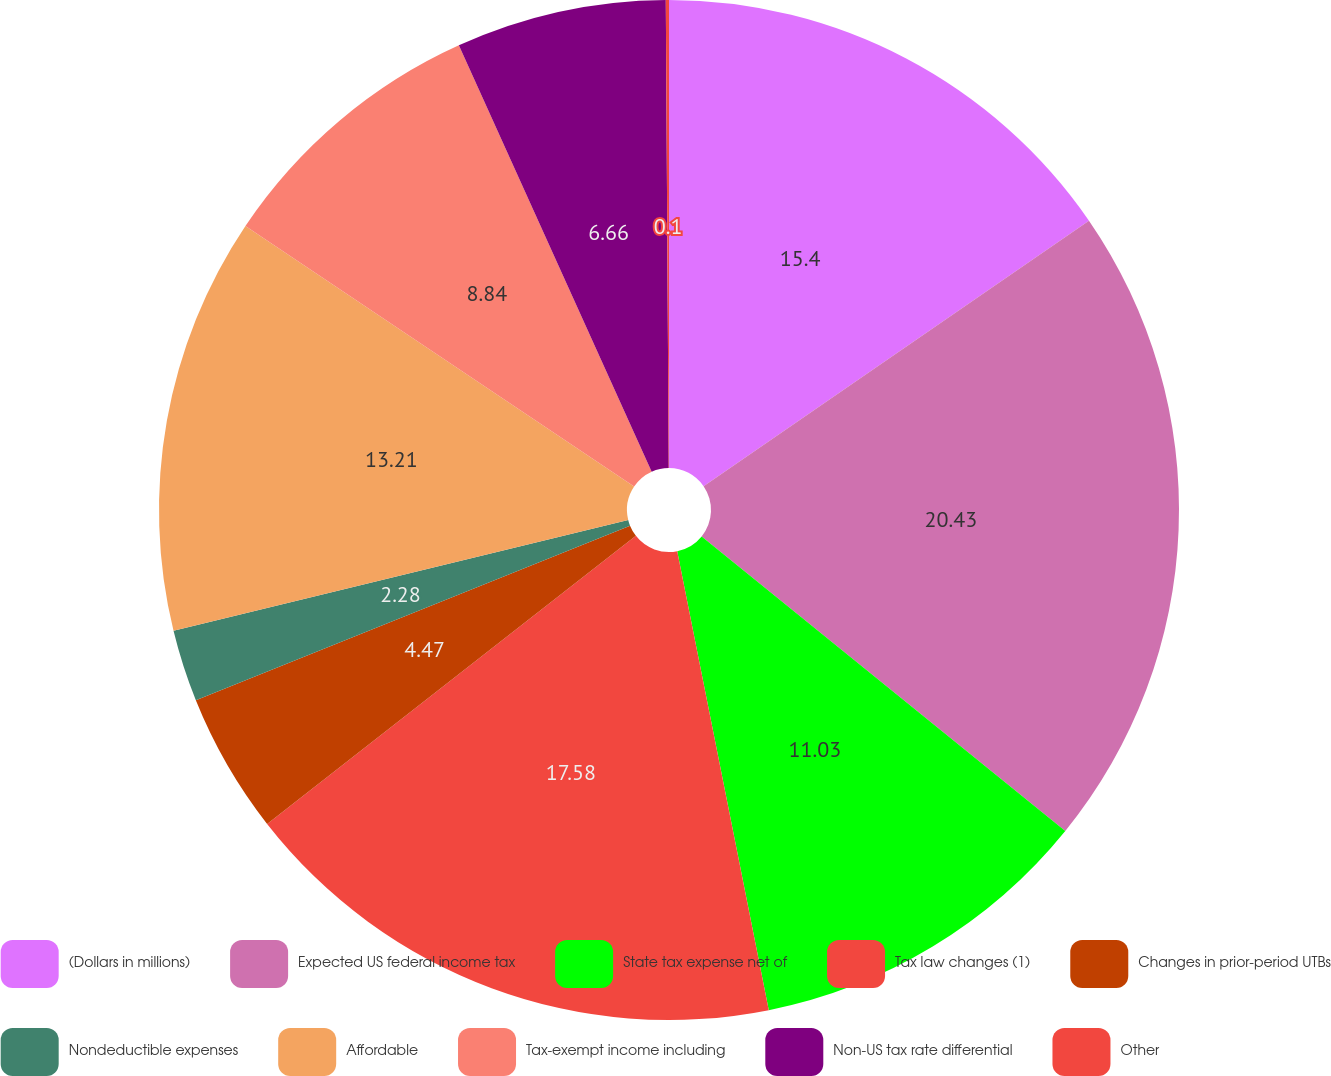Convert chart. <chart><loc_0><loc_0><loc_500><loc_500><pie_chart><fcel>(Dollars in millions)<fcel>Expected US federal income tax<fcel>State tax expense net of<fcel>Tax law changes (1)<fcel>Changes in prior-period UTBs<fcel>Nondeductible expenses<fcel>Affordable<fcel>Tax-exempt income including<fcel>Non-US tax rate differential<fcel>Other<nl><fcel>15.4%<fcel>20.44%<fcel>11.03%<fcel>17.58%<fcel>4.47%<fcel>2.28%<fcel>13.21%<fcel>8.84%<fcel>6.66%<fcel>0.1%<nl></chart> 